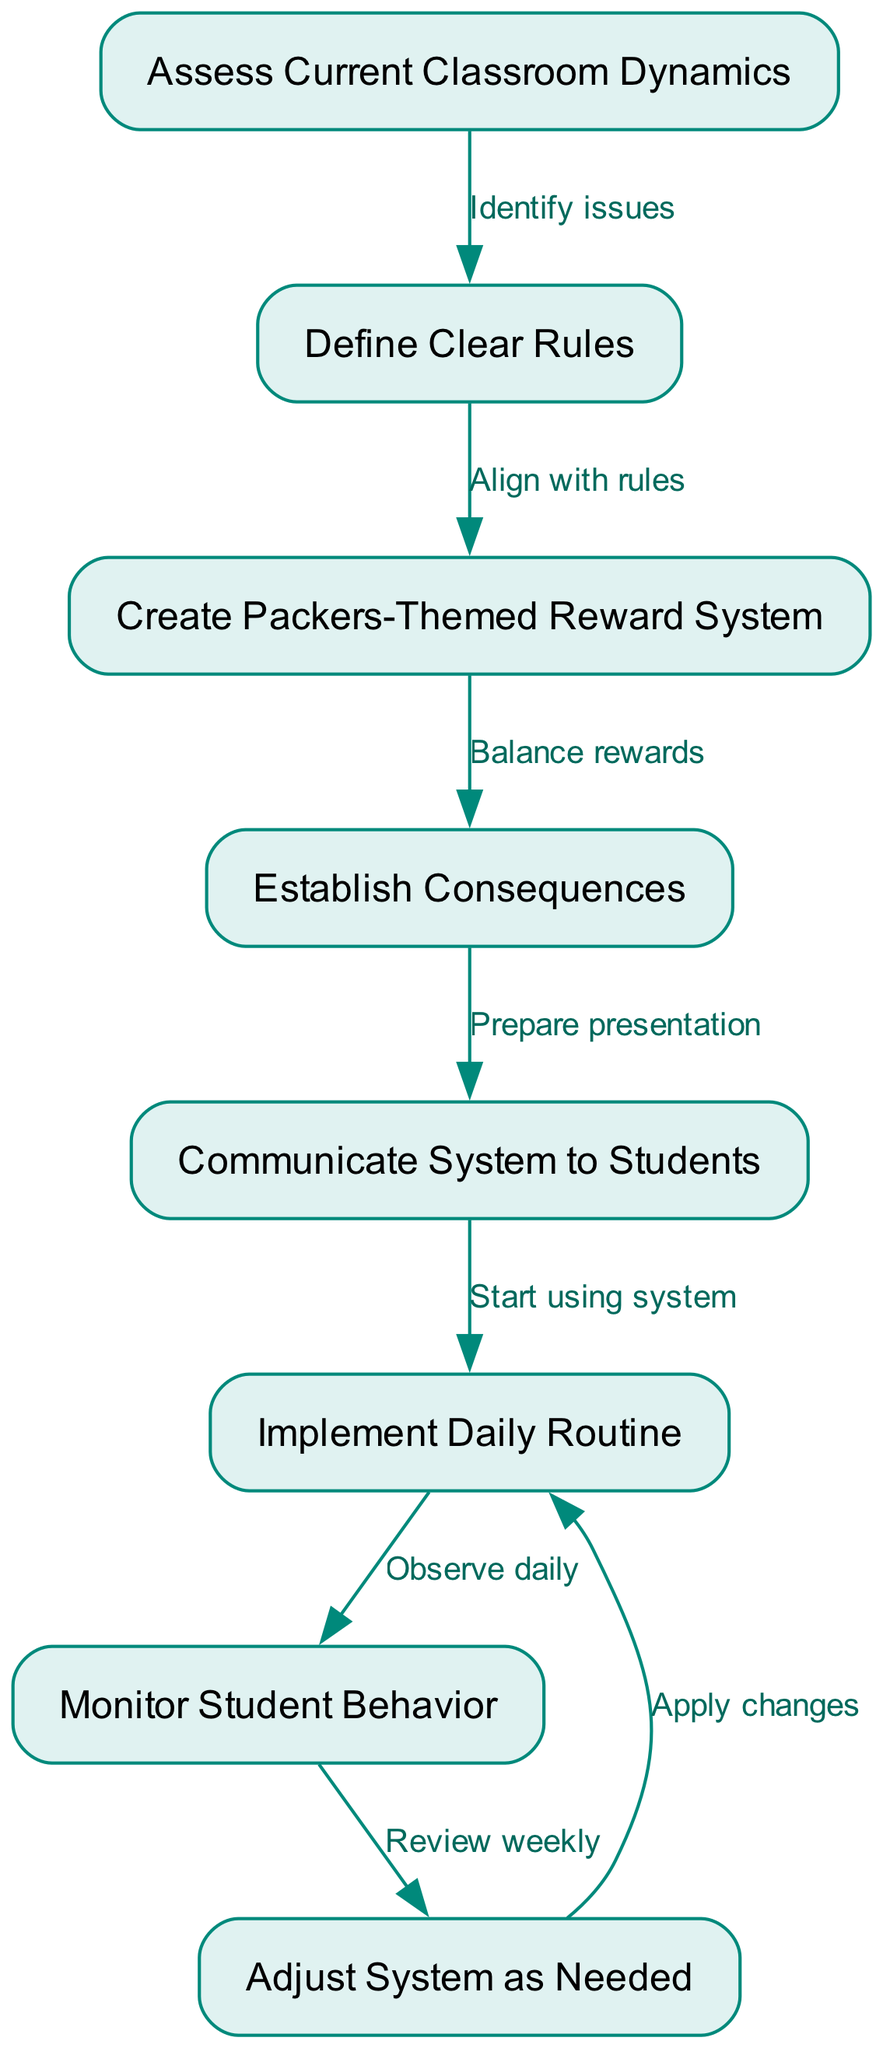What is the starting node of the diagram? The starting node is clearly labeled as "Assess Current Classroom Dynamics," which serves as the initiation point of the functional flow.
Answer: Assess Current Classroom Dynamics How many nodes are in the diagram? By counting each unique step represented, we can identify there are 7 nodes including the start node, which leads to activities related to classroom management.
Answer: 7 What is the label on the edge leading from "Define Clear Rules" to "Create Packers-Themed Reward System"? Referring to the edge connecting these nodes, it is labeled "Align with rules," indicating the purpose of this transition in the flowchart.
Answer: Align with rules What action follows "Monitor Student Behavior"? Following the "Monitor Student Behavior" node, the next action indicated in the flow is "Adjust System as Needed," representing a feedback loop for further refinement.
Answer: Adjust System as Needed Which node is directly connected to "Establish Consequences"? The diagram shows that "Establish Consequences" is directly linked to "Communicate System to Students," making it the immediate next step in the process.
Answer: Communicate System to Students What happens after "Implement Daily Routine"? After the "Implement Daily Routine" step, the process leads to the "Monitor Student Behavior" node, indicating that observation is essential at this stage.
Answer: Monitor Student Behavior How would you describe the flow between "Adjust System as Needed" and "Implement Daily Routine"? The connection from "Adjust System as Needed" back to "Implement Daily Routine" signifies a cyclical process where adjustments may need to be made for continuous improvement and application.
Answer: Apply changes What is the purpose of the first edge in the diagram? The first edge from "Assess Current Classroom Dynamics" to "Define Clear Rules" is labeled "Identify issues," indicating it serves to initiate an evaluation process for rule establishment.
Answer: Identify issues 